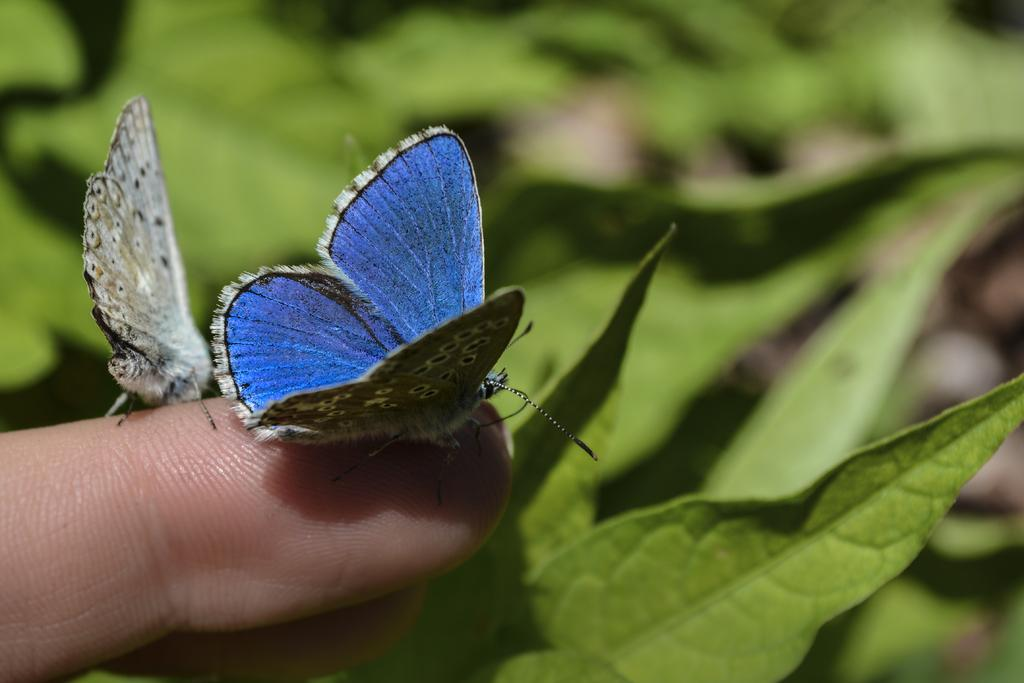What type of animals can be seen in the image? There are butterflies in the image. Where are the butterflies located? The butterflies are on a finger. What can be seen in the background of the image? There are leaves in the background of the image. What type of glue is being used to attach the butterflies to the finger in the image? There is no glue present in the image; the butterflies are simply resting on the finger. How does the bridge in the image connect to the butterflies? There is no bridge present in the image; it only features butterflies on a finger and leaves in the background. 